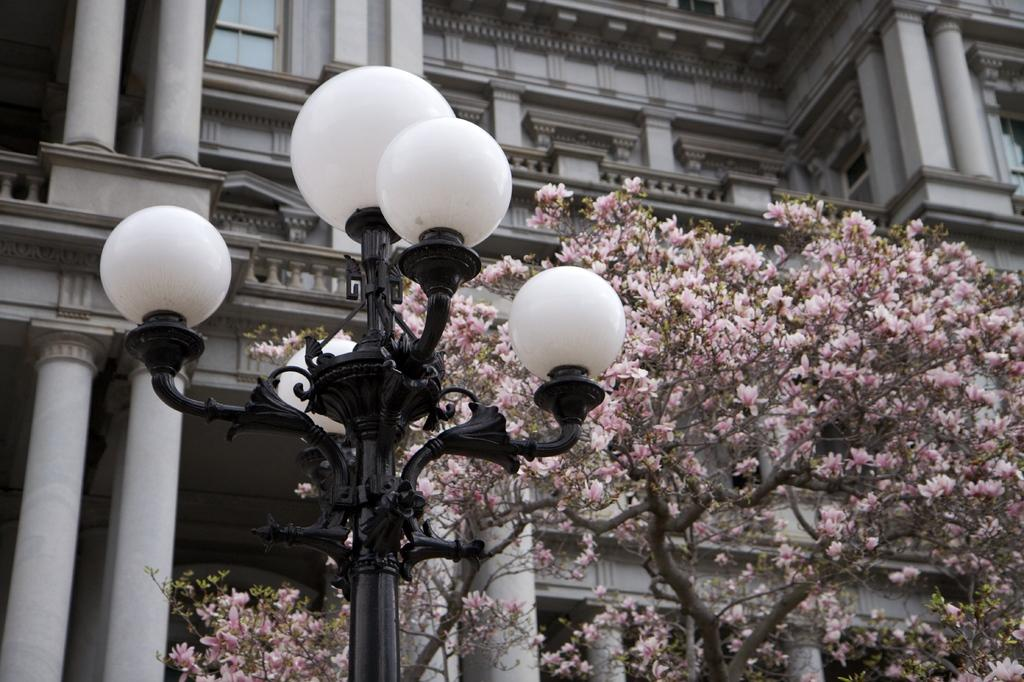What type of structure is visible in the image? There is a building in the image. What architectural features can be seen on the building? The building has pillars and windows. What else can be seen in the image besides the building? There is a street pole, street lights, and a tree with flowers in the flowers in the image. What type of advertisement is displayed on the farmer's map in the image? There is no farmer or map present in the image, so it is not possible to answer that question. 